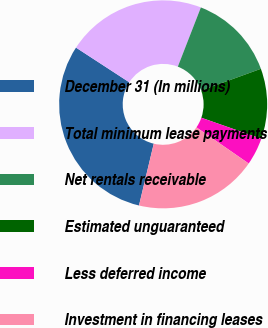Convert chart to OTSL. <chart><loc_0><loc_0><loc_500><loc_500><pie_chart><fcel>December 31 (In millions)<fcel>Total minimum lease payments<fcel>Net rentals receivable<fcel>Estimated unguaranteed<fcel>Less deferred income<fcel>Investment in financing leases<nl><fcel>30.45%<fcel>21.72%<fcel>13.54%<fcel>10.92%<fcel>4.26%<fcel>19.1%<nl></chart> 